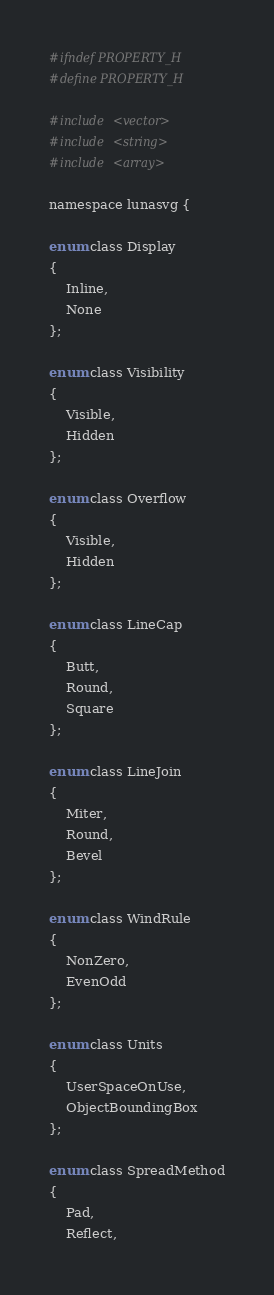<code> <loc_0><loc_0><loc_500><loc_500><_C_>#ifndef PROPERTY_H
#define PROPERTY_H

#include <vector>
#include <string>
#include <array>

namespace lunasvg {

enum class Display
{
    Inline,
    None
};

enum class Visibility
{
    Visible,
    Hidden
};

enum class Overflow
{
    Visible,
    Hidden
};

enum class LineCap
{
    Butt,
    Round,
    Square
};

enum class LineJoin
{
    Miter,
    Round,
    Bevel
};

enum class WindRule
{
    NonZero,
    EvenOdd
};

enum class Units
{
    UserSpaceOnUse,
    ObjectBoundingBox
};

enum class SpreadMethod
{
    Pad,
    Reflect,</code> 